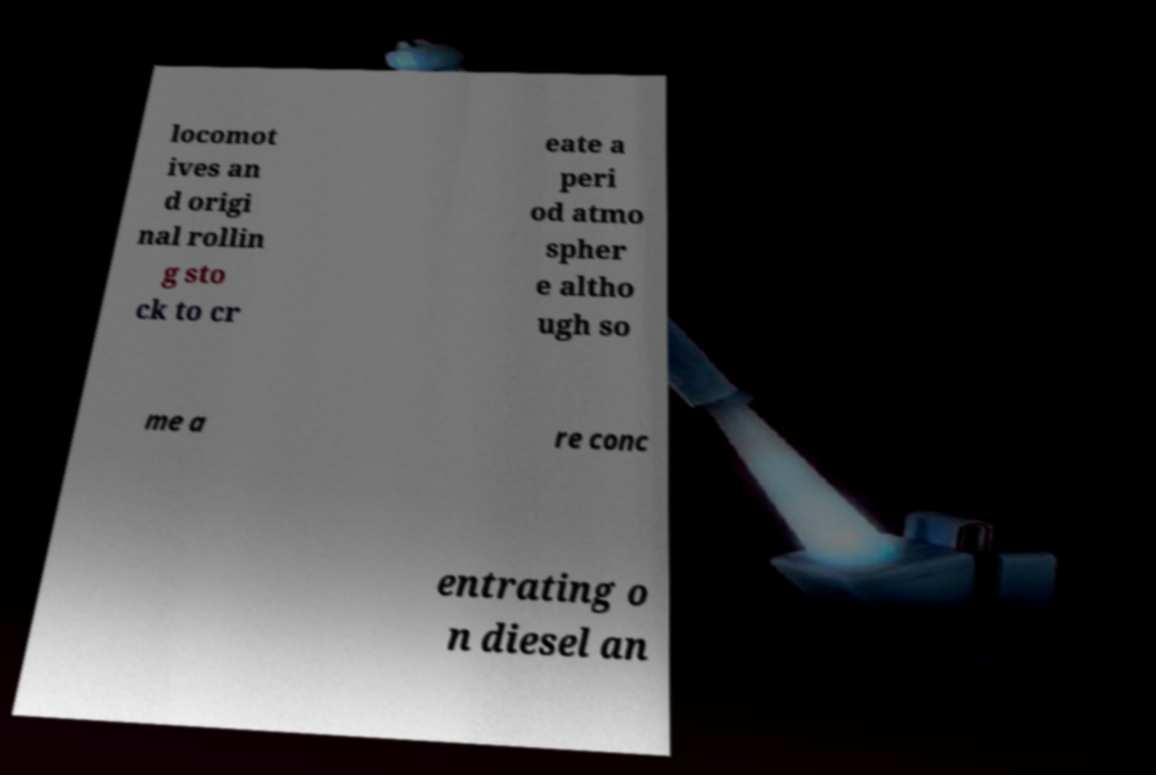What messages or text are displayed in this image? I need them in a readable, typed format. locomot ives an d origi nal rollin g sto ck to cr eate a peri od atmo spher e altho ugh so me a re conc entrating o n diesel an 